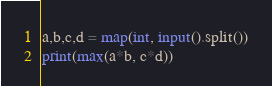<code> <loc_0><loc_0><loc_500><loc_500><_Python_>a,b,c,d = map(int, input().split())
print(max(a*b, c*d))</code> 